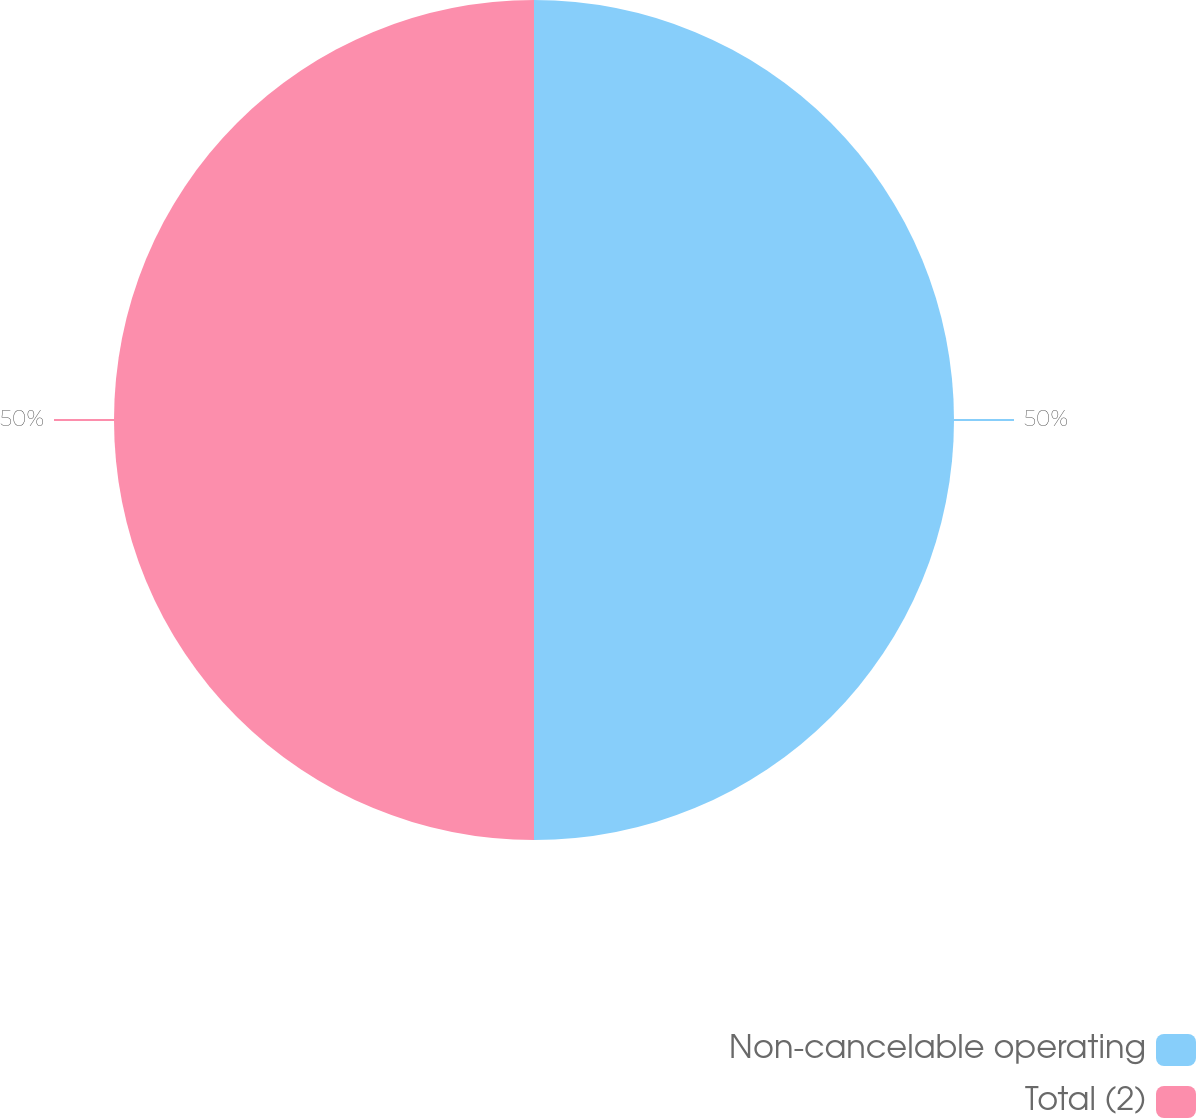Convert chart to OTSL. <chart><loc_0><loc_0><loc_500><loc_500><pie_chart><fcel>Non-cancelable operating<fcel>Total (2)<nl><fcel>50.0%<fcel>50.0%<nl></chart> 